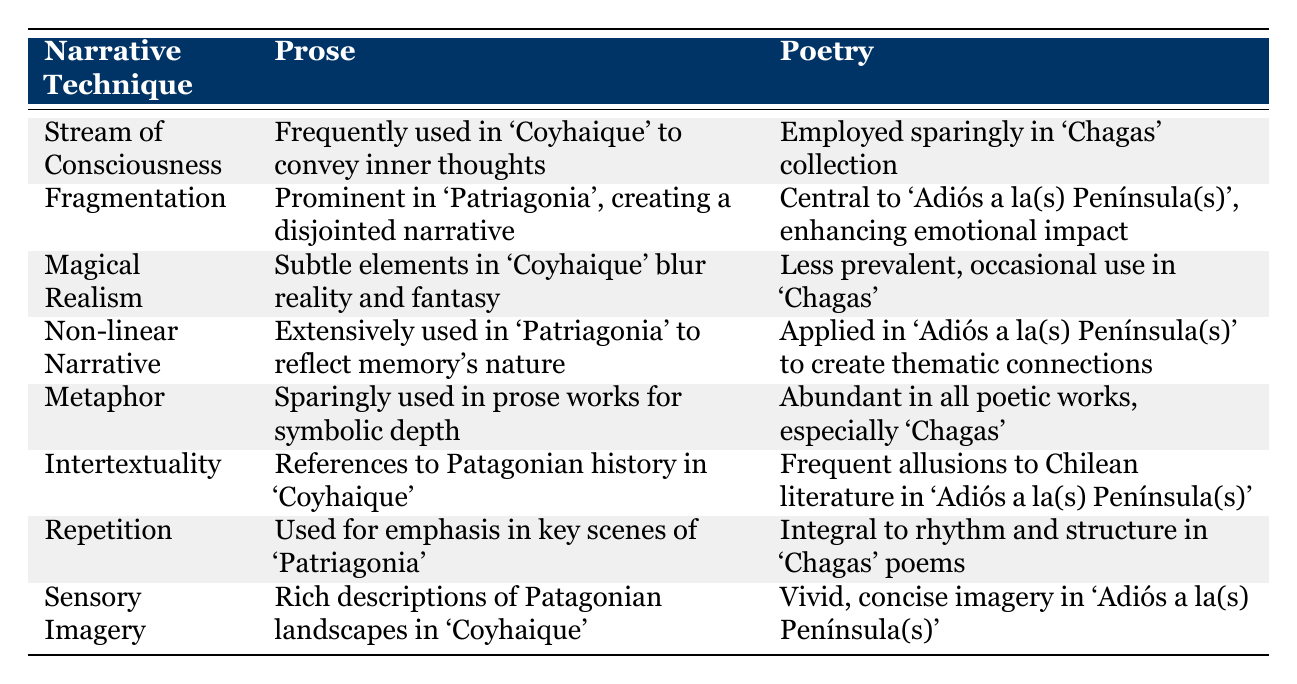What narrative technique is prominently used in Coñuecar's poetry in 'Adiós a la(s) Península(s)'? The table indicates that fragmentation is central to 'Adiós a la(s) Península(s)', which is a direct reference to the poetry section.
Answer: Fragmentation Is the stream of consciousness technique used more in Coñuecar's prose or poetry? According to the table, stream of consciousness is frequently used in prose, specifically in 'Coyhaique', while it is employed sparingly in the poetry collection 'Chagas'. Therefore, it is used more in prose.
Answer: More in prose How many narrative techniques are mentioned in total? The table lists eight narrative techniques. By counting the rows under the "Narrative Technique" column, we confirm there are eight distinct techniques.
Answer: Eight Does Coñuecar employ metaphor more in poetry or prose? The table shows that metaphor is sparingly used in prose works for symbolic depth, while it is abundant in poetry, especially in 'Chagas'. Therefore, Coñuecar employs metaphor more in poetry.
Answer: More in poetry Which technique involves non-linear narrative in both prose and poetry? The table indicates that non-linear narrative is extensively used in 'Patriagonia', which is prose, and is also applied in 'Adiós a la(s) Península(s)', which is poetry. Therefore, it is the same technique present in both works.
Answer: Non-linear Narrative What is the difference in the frequency of sensory imagery usage between prose and poetry? In prose, rich descriptions of Patagonian landscapes are used in 'Coyhaique', while in poetry, there is vivid, concise imagery in 'Adiós a la(s) Península(s)'. This implies sensory imagery is used differently rather than a difference in frequency.
Answer: Different usage, not frequency In how many techniques were magical realism mentioned across both prose and poetry? The table mentions magical realism in both prose (subtle elements in 'Coyhaique') and poetry (less prevalent, occasional use in 'Chagas'), indicating its presence in both genres. Thus, it is mentioned in two techniques total.
Answer: Two techniques True or False: Repetition is integral to the structure of Coñuecar's prose works. The table states that repetition is used for emphasis in key scenes of 'Patriagonia', but it clarifies that it is integral to rhythm and structure in 'Chagas' poems. Thus, the statement is false regarding prose.
Answer: False 